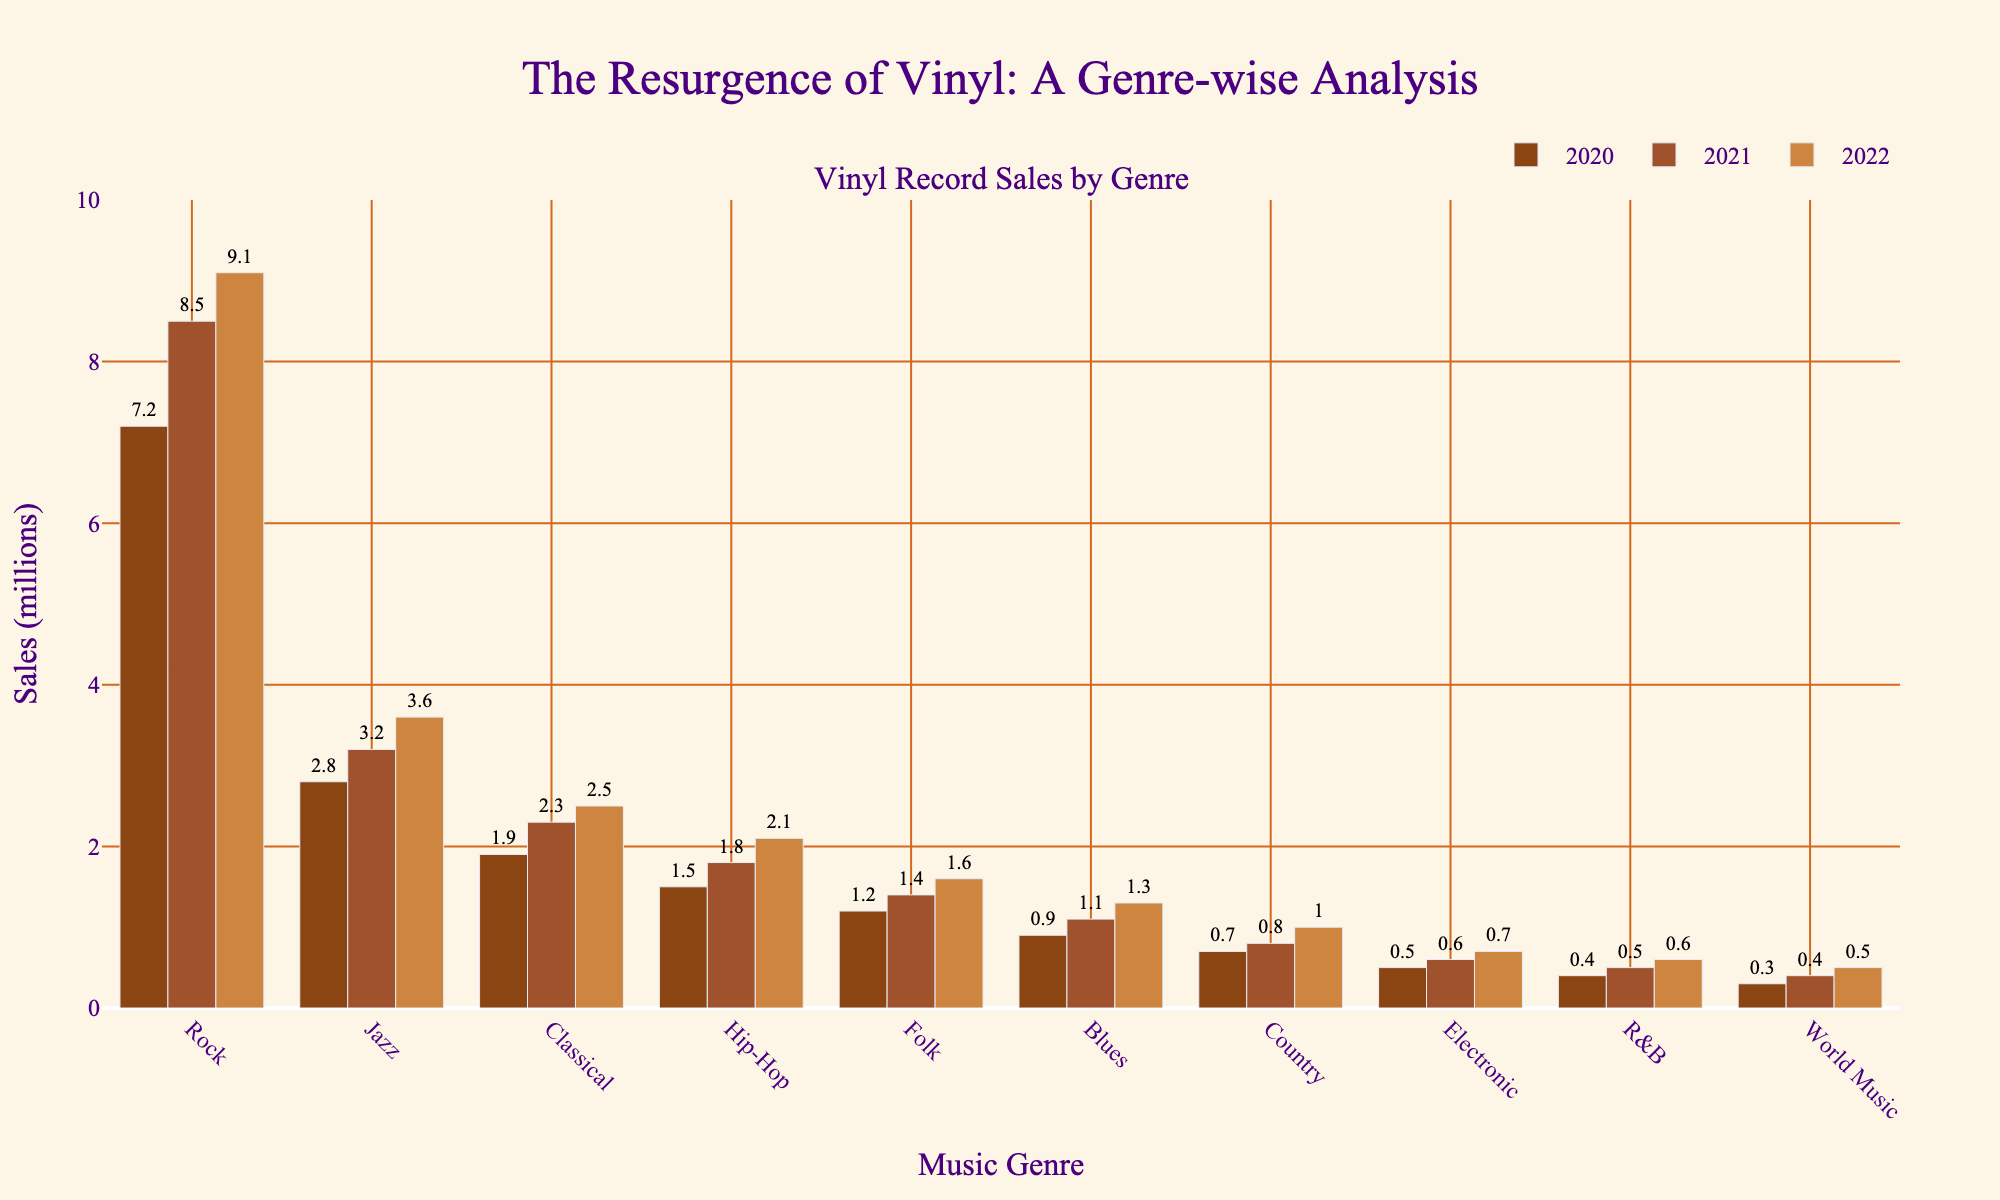What was the sales figure for Rock in 2021? The height of the bar representing Rock in the 2021 sales category is around 8.5 million, as indicated by the figure.
Answer: 8.5 million How much did Jazz vinyl record sales grow from 2020 to 2022? The Jazz sales were 2.8 million in 2020 and 3.6 million in 2022. The growth is 3.6 - 2.8 = 0.8 million.
Answer: 0.8 million Which genre had the largest sales increase from 2020 to 2022? To find the largest increase, compare the sales differences between 2020 and 2022 for each genre. Rock increased by 9.1 - 7.2 = 1.9 million, which is the largest increase.
Answer: Rock What is the combined sales value of all genres in 2020? Sum the sales figures for all genres in 2020: 7.2 + 2.8 + 1.9 + 1.5 + 1.2 + 0.9 + 0.7 + 0.5 + 0.4 + 0.3 = 17.4 million.
Answer: 17.4 million Which genre had the least sales in 2022 and what was the amount? The bar for World Music in the 2022 sales category is the shortest, showing 0.5 million in sales.
Answer: World Music, 0.5 million How much more did Rock records sell compared to Classical records in 2021? Subtract the Classical sales figure from the Rock sales figure for 2021: 8.5 - 2.3 = 6.2 million.
Answer: 6.2 million What was the average sales figure across all genres in 2022? Sum the 2022 sales figures and then divide by the number of genres: (9.1 + 3.6 + 2.5 + 2.1 + 1.6 + 1.3 + 1.0 + 0.7 + 0.6 + 0.5) / 10 = 2.8 million.
Answer: 2.8 million Which three genres had the highest sales in 2022? Visually identify the three tallest bars in the 2022 sales category: Rock, Jazz, and Classical.
Answer: Rock, Jazz, Classical Compare Blues and Country sales growth from 2020 to 2022 and identify which grew more. Blues grew from 0.9 to 1.3 million, an increase of 0.4 million. Country grew from 0.7 to 1.0 million, an increase of 0.3 million. Therefore, Blues grew more.
Answer: Blues What is the difference in vinyl sales between Electronic and Folk genres in 2021? Subtract the Electronic sales figure from the Folk sales figure for 2021: 1.4 - 0.6 = 0.8 million.
Answer: 0.8 million 